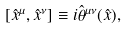<formula> <loc_0><loc_0><loc_500><loc_500>[ \hat { x } ^ { \mu } , \hat { x } ^ { \nu } ] \equiv i \hat { \theta } ^ { \mu \nu } ( \hat { x } ) ,</formula> 